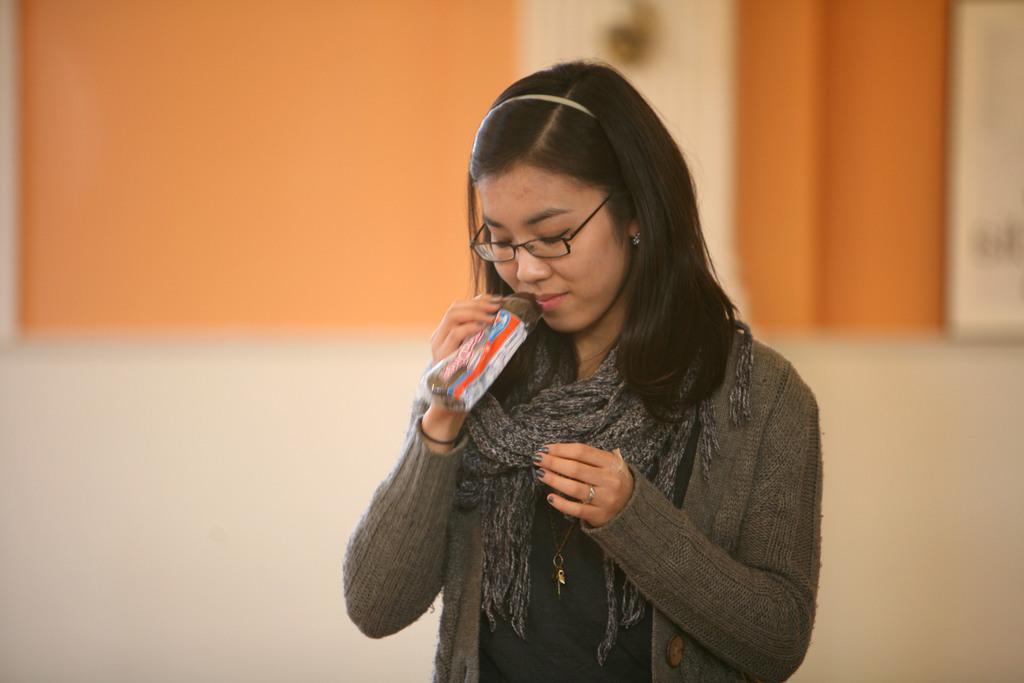How would you summarize this image in a sentence or two? In the foreground of the image there is a lady wearing a jacket. In the background of the image there is wall. 